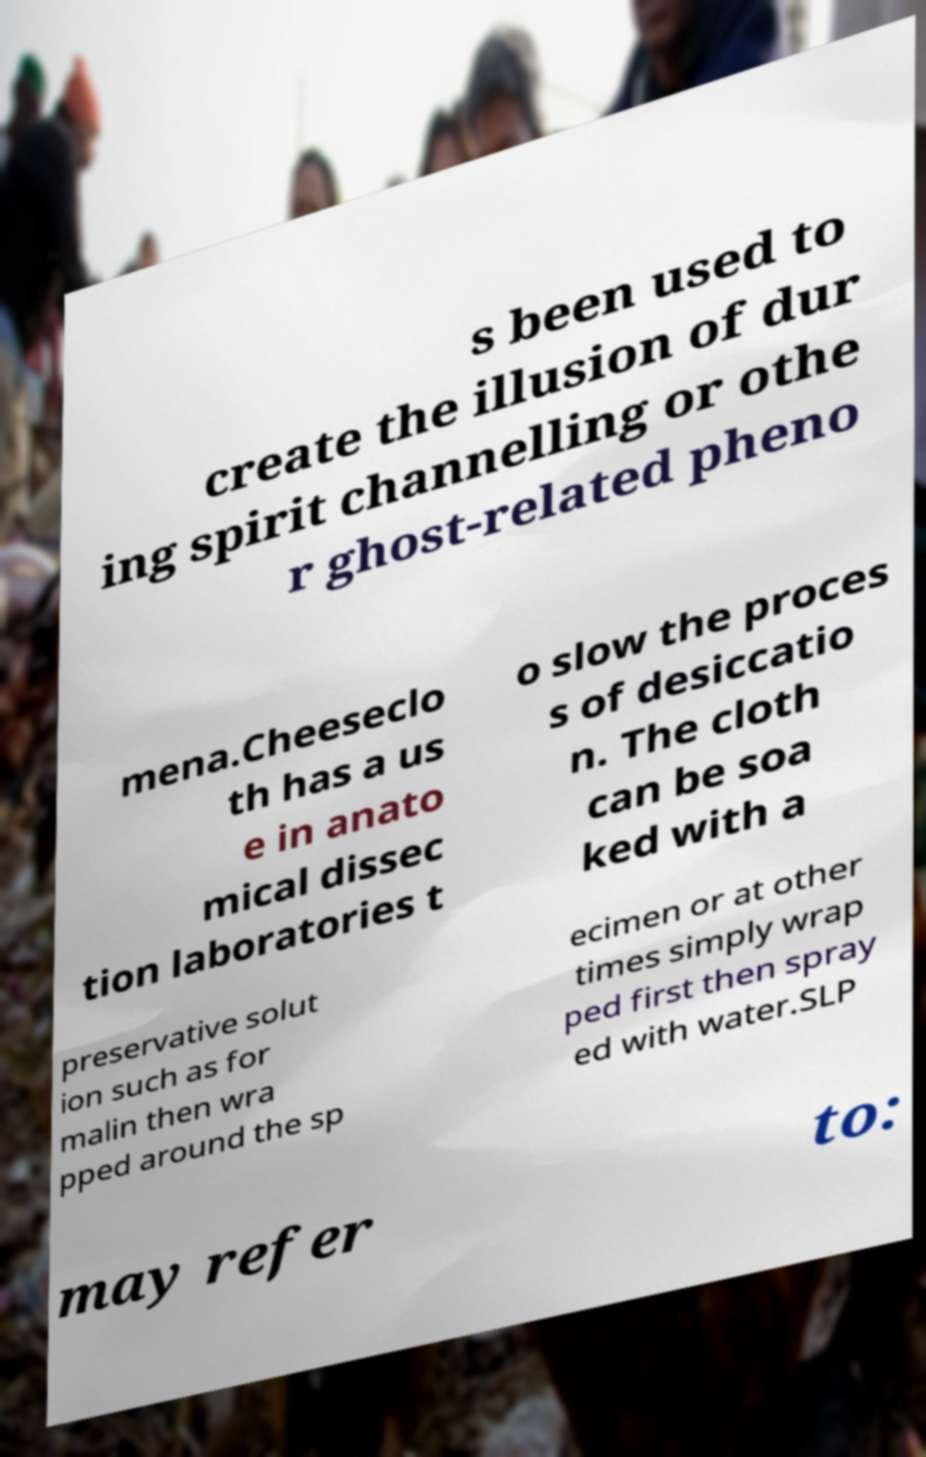I need the written content from this picture converted into text. Can you do that? s been used to create the illusion of dur ing spirit channelling or othe r ghost-related pheno mena.Cheeseclo th has a us e in anato mical dissec tion laboratories t o slow the proces s of desiccatio n. The cloth can be soa ked with a preservative solut ion such as for malin then wra pped around the sp ecimen or at other times simply wrap ped first then spray ed with water.SLP may refer to: 